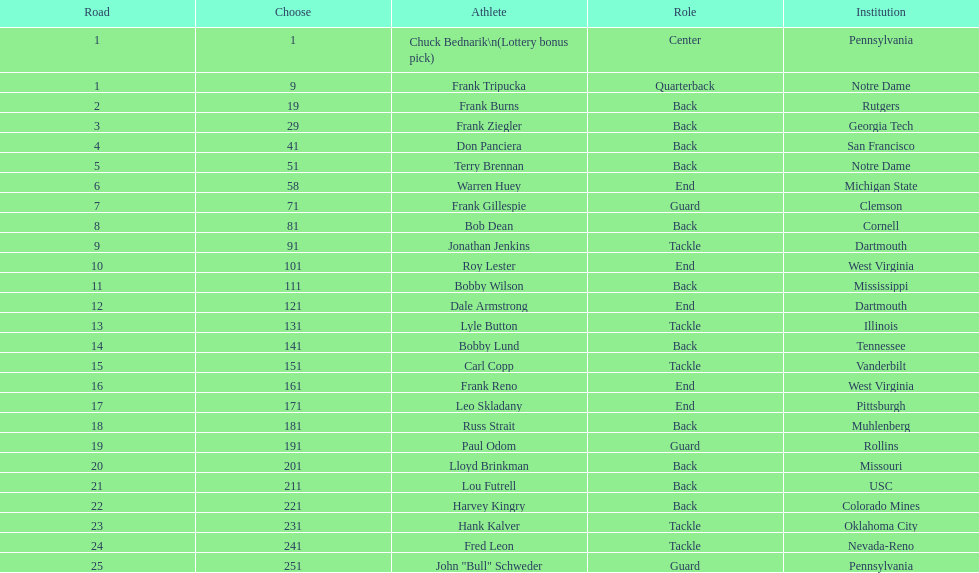Who has same position as frank gillespie? Paul Odom, John "Bull" Schweder. 